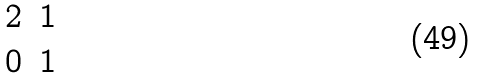<formula> <loc_0><loc_0><loc_500><loc_500>\begin{matrix} 2 & 1 \\ 0 & 1 \end{matrix}</formula> 